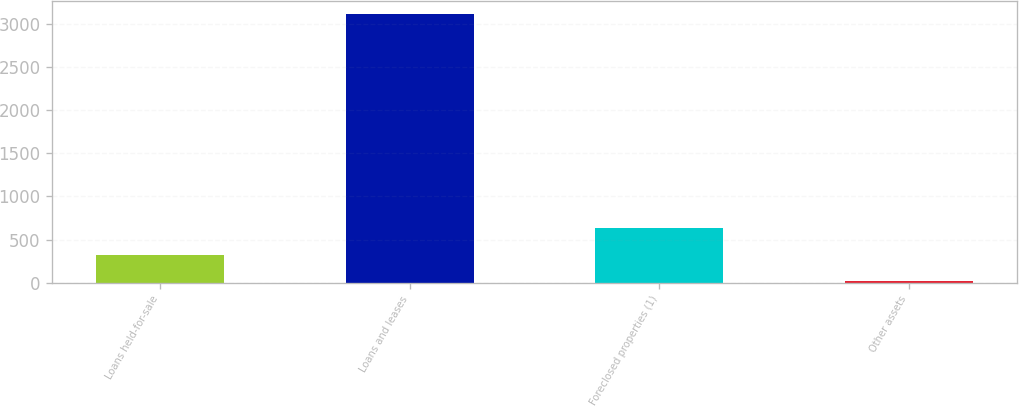Convert chart to OTSL. <chart><loc_0><loc_0><loc_500><loc_500><bar_chart><fcel>Loans held-for-sale<fcel>Loans and leases<fcel>Foreclosed properties (1)<fcel>Other assets<nl><fcel>326<fcel>3116<fcel>636<fcel>16<nl></chart> 